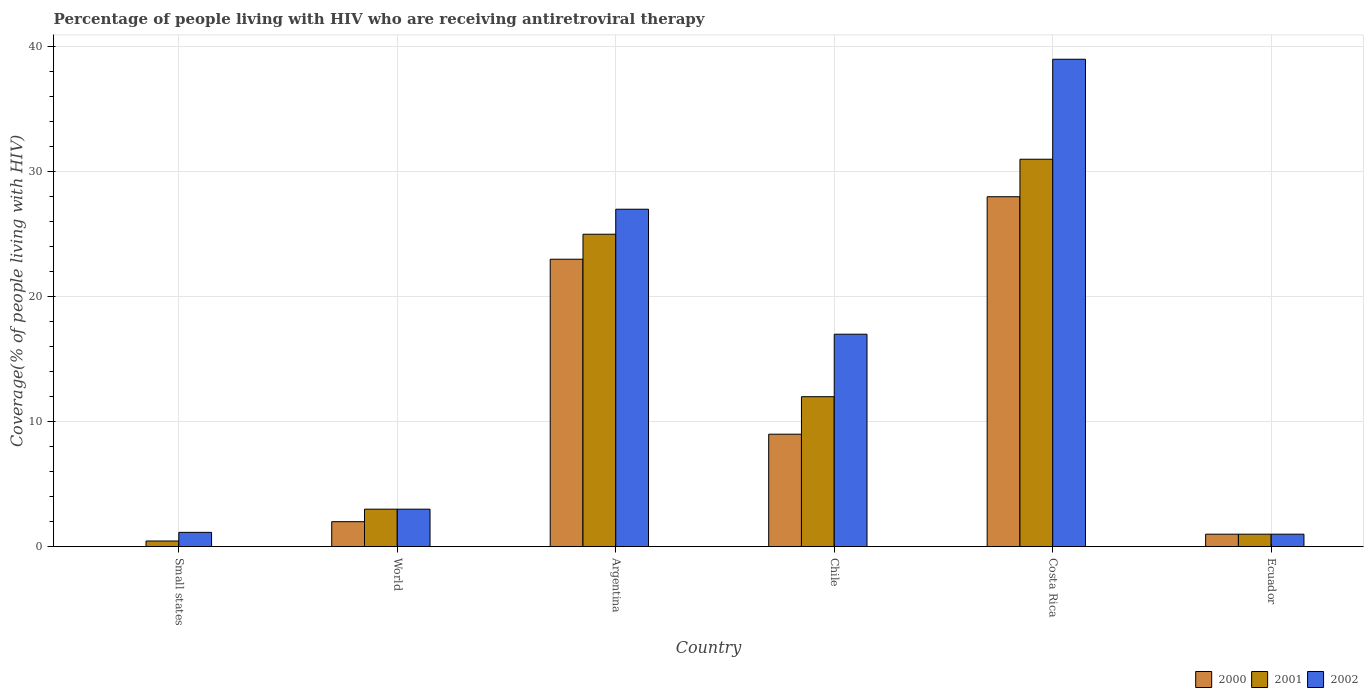What is the label of the 3rd group of bars from the left?
Provide a succinct answer. Argentina. In how many cases, is the number of bars for a given country not equal to the number of legend labels?
Provide a short and direct response. 0. What is the percentage of the HIV infected people who are receiving antiretroviral therapy in 2002 in Chile?
Provide a succinct answer. 17. Across all countries, what is the maximum percentage of the HIV infected people who are receiving antiretroviral therapy in 2002?
Your response must be concise. 39. In which country was the percentage of the HIV infected people who are receiving antiretroviral therapy in 2000 minimum?
Provide a succinct answer. Small states. What is the total percentage of the HIV infected people who are receiving antiretroviral therapy in 2001 in the graph?
Ensure brevity in your answer.  72.45. What is the difference between the percentage of the HIV infected people who are receiving antiretroviral therapy in 2002 in Ecuador and that in World?
Offer a terse response. -2. What is the difference between the percentage of the HIV infected people who are receiving antiretroviral therapy in 2002 in Chile and the percentage of the HIV infected people who are receiving antiretroviral therapy in 2001 in World?
Make the answer very short. 14. What is the average percentage of the HIV infected people who are receiving antiretroviral therapy in 2002 per country?
Provide a short and direct response. 14.69. What is the difference between the percentage of the HIV infected people who are receiving antiretroviral therapy of/in 2001 and percentage of the HIV infected people who are receiving antiretroviral therapy of/in 2002 in Small states?
Offer a very short reply. -0.69. What is the ratio of the percentage of the HIV infected people who are receiving antiretroviral therapy in 2001 in Costa Rica to that in Small states?
Offer a terse response. 68.14. Is the percentage of the HIV infected people who are receiving antiretroviral therapy in 2002 in Argentina less than that in Costa Rica?
Keep it short and to the point. Yes. Is the difference between the percentage of the HIV infected people who are receiving antiretroviral therapy in 2001 in Argentina and Chile greater than the difference between the percentage of the HIV infected people who are receiving antiretroviral therapy in 2002 in Argentina and Chile?
Your answer should be compact. Yes. What is the difference between the highest and the lowest percentage of the HIV infected people who are receiving antiretroviral therapy in 2002?
Provide a short and direct response. 38. In how many countries, is the percentage of the HIV infected people who are receiving antiretroviral therapy in 2002 greater than the average percentage of the HIV infected people who are receiving antiretroviral therapy in 2002 taken over all countries?
Offer a very short reply. 3. What does the 1st bar from the left in World represents?
Make the answer very short. 2000. What does the 1st bar from the right in World represents?
Make the answer very short. 2002. Is it the case that in every country, the sum of the percentage of the HIV infected people who are receiving antiretroviral therapy in 2000 and percentage of the HIV infected people who are receiving antiretroviral therapy in 2002 is greater than the percentage of the HIV infected people who are receiving antiretroviral therapy in 2001?
Give a very brief answer. Yes. How many bars are there?
Your response must be concise. 18. Are all the bars in the graph horizontal?
Provide a short and direct response. No. How many countries are there in the graph?
Offer a terse response. 6. What is the difference between two consecutive major ticks on the Y-axis?
Provide a short and direct response. 10. Does the graph contain any zero values?
Keep it short and to the point. No. Where does the legend appear in the graph?
Provide a succinct answer. Bottom right. How are the legend labels stacked?
Ensure brevity in your answer.  Horizontal. What is the title of the graph?
Offer a terse response. Percentage of people living with HIV who are receiving antiretroviral therapy. What is the label or title of the Y-axis?
Provide a succinct answer. Coverage(% of people living with HIV). What is the Coverage(% of people living with HIV) of 2000 in Small states?
Give a very brief answer. 0.01. What is the Coverage(% of people living with HIV) in 2001 in Small states?
Keep it short and to the point. 0.45. What is the Coverage(% of people living with HIV) of 2002 in Small states?
Ensure brevity in your answer.  1.15. What is the Coverage(% of people living with HIV) in 2001 in World?
Offer a very short reply. 3. What is the Coverage(% of people living with HIV) in 2000 in Chile?
Give a very brief answer. 9. What is the Coverage(% of people living with HIV) in 2000 in Costa Rica?
Make the answer very short. 28. What is the Coverage(% of people living with HIV) in 2001 in Costa Rica?
Give a very brief answer. 31. What is the Coverage(% of people living with HIV) of 2000 in Ecuador?
Your answer should be compact. 1. Across all countries, what is the minimum Coverage(% of people living with HIV) in 2000?
Your response must be concise. 0.01. Across all countries, what is the minimum Coverage(% of people living with HIV) of 2001?
Keep it short and to the point. 0.45. Across all countries, what is the minimum Coverage(% of people living with HIV) of 2002?
Provide a succinct answer. 1. What is the total Coverage(% of people living with HIV) in 2000 in the graph?
Provide a short and direct response. 63.01. What is the total Coverage(% of people living with HIV) of 2001 in the graph?
Offer a very short reply. 72.45. What is the total Coverage(% of people living with HIV) in 2002 in the graph?
Provide a succinct answer. 88.15. What is the difference between the Coverage(% of people living with HIV) of 2000 in Small states and that in World?
Give a very brief answer. -1.99. What is the difference between the Coverage(% of people living with HIV) of 2001 in Small states and that in World?
Your response must be concise. -2.54. What is the difference between the Coverage(% of people living with HIV) in 2002 in Small states and that in World?
Keep it short and to the point. -1.85. What is the difference between the Coverage(% of people living with HIV) in 2000 in Small states and that in Argentina?
Provide a short and direct response. -22.99. What is the difference between the Coverage(% of people living with HIV) in 2001 in Small states and that in Argentina?
Your answer should be very brief. -24.55. What is the difference between the Coverage(% of people living with HIV) of 2002 in Small states and that in Argentina?
Offer a very short reply. -25.85. What is the difference between the Coverage(% of people living with HIV) of 2000 in Small states and that in Chile?
Keep it short and to the point. -8.99. What is the difference between the Coverage(% of people living with HIV) of 2001 in Small states and that in Chile?
Make the answer very short. -11.54. What is the difference between the Coverage(% of people living with HIV) of 2002 in Small states and that in Chile?
Ensure brevity in your answer.  -15.85. What is the difference between the Coverage(% of people living with HIV) of 2000 in Small states and that in Costa Rica?
Your answer should be compact. -27.99. What is the difference between the Coverage(% of people living with HIV) of 2001 in Small states and that in Costa Rica?
Give a very brief answer. -30.55. What is the difference between the Coverage(% of people living with HIV) of 2002 in Small states and that in Costa Rica?
Your answer should be compact. -37.85. What is the difference between the Coverage(% of people living with HIV) in 2000 in Small states and that in Ecuador?
Give a very brief answer. -0.99. What is the difference between the Coverage(% of people living with HIV) in 2001 in Small states and that in Ecuador?
Keep it short and to the point. -0.55. What is the difference between the Coverage(% of people living with HIV) in 2002 in Small states and that in Ecuador?
Ensure brevity in your answer.  0.15. What is the difference between the Coverage(% of people living with HIV) in 2000 in World and that in Argentina?
Provide a short and direct response. -21. What is the difference between the Coverage(% of people living with HIV) of 2001 in World and that in Argentina?
Offer a very short reply. -22. What is the difference between the Coverage(% of people living with HIV) in 2002 in World and that in Argentina?
Your response must be concise. -24. What is the difference between the Coverage(% of people living with HIV) in 2000 in World and that in Chile?
Make the answer very short. -7. What is the difference between the Coverage(% of people living with HIV) of 2001 in World and that in Chile?
Give a very brief answer. -9. What is the difference between the Coverage(% of people living with HIV) of 2000 in World and that in Costa Rica?
Give a very brief answer. -26. What is the difference between the Coverage(% of people living with HIV) of 2001 in World and that in Costa Rica?
Your response must be concise. -28. What is the difference between the Coverage(% of people living with HIV) of 2002 in World and that in Costa Rica?
Provide a short and direct response. -36. What is the difference between the Coverage(% of people living with HIV) of 2000 in World and that in Ecuador?
Offer a very short reply. 1. What is the difference between the Coverage(% of people living with HIV) in 2002 in World and that in Ecuador?
Provide a succinct answer. 2. What is the difference between the Coverage(% of people living with HIV) in 2001 in Argentina and that in Chile?
Offer a very short reply. 13. What is the difference between the Coverage(% of people living with HIV) of 2000 in Argentina and that in Costa Rica?
Give a very brief answer. -5. What is the difference between the Coverage(% of people living with HIV) in 2002 in Argentina and that in Costa Rica?
Offer a very short reply. -12. What is the difference between the Coverage(% of people living with HIV) in 2002 in Argentina and that in Ecuador?
Provide a succinct answer. 26. What is the difference between the Coverage(% of people living with HIV) of 2000 in Chile and that in Costa Rica?
Offer a terse response. -19. What is the difference between the Coverage(% of people living with HIV) of 2001 in Chile and that in Costa Rica?
Provide a succinct answer. -19. What is the difference between the Coverage(% of people living with HIV) of 2002 in Chile and that in Ecuador?
Ensure brevity in your answer.  16. What is the difference between the Coverage(% of people living with HIV) in 2000 in Costa Rica and that in Ecuador?
Keep it short and to the point. 27. What is the difference between the Coverage(% of people living with HIV) of 2001 in Costa Rica and that in Ecuador?
Your answer should be very brief. 30. What is the difference between the Coverage(% of people living with HIV) of 2000 in Small states and the Coverage(% of people living with HIV) of 2001 in World?
Your answer should be compact. -2.99. What is the difference between the Coverage(% of people living with HIV) of 2000 in Small states and the Coverage(% of people living with HIV) of 2002 in World?
Provide a short and direct response. -2.99. What is the difference between the Coverage(% of people living with HIV) in 2001 in Small states and the Coverage(% of people living with HIV) in 2002 in World?
Your response must be concise. -2.54. What is the difference between the Coverage(% of people living with HIV) in 2000 in Small states and the Coverage(% of people living with HIV) in 2001 in Argentina?
Keep it short and to the point. -24.99. What is the difference between the Coverage(% of people living with HIV) in 2000 in Small states and the Coverage(% of people living with HIV) in 2002 in Argentina?
Provide a succinct answer. -26.99. What is the difference between the Coverage(% of people living with HIV) in 2001 in Small states and the Coverage(% of people living with HIV) in 2002 in Argentina?
Your response must be concise. -26.55. What is the difference between the Coverage(% of people living with HIV) of 2000 in Small states and the Coverage(% of people living with HIV) of 2001 in Chile?
Offer a terse response. -11.99. What is the difference between the Coverage(% of people living with HIV) in 2000 in Small states and the Coverage(% of people living with HIV) in 2002 in Chile?
Keep it short and to the point. -16.99. What is the difference between the Coverage(% of people living with HIV) of 2001 in Small states and the Coverage(% of people living with HIV) of 2002 in Chile?
Ensure brevity in your answer.  -16.55. What is the difference between the Coverage(% of people living with HIV) in 2000 in Small states and the Coverage(% of people living with HIV) in 2001 in Costa Rica?
Offer a very short reply. -30.99. What is the difference between the Coverage(% of people living with HIV) of 2000 in Small states and the Coverage(% of people living with HIV) of 2002 in Costa Rica?
Keep it short and to the point. -38.99. What is the difference between the Coverage(% of people living with HIV) in 2001 in Small states and the Coverage(% of people living with HIV) in 2002 in Costa Rica?
Your response must be concise. -38.55. What is the difference between the Coverage(% of people living with HIV) of 2000 in Small states and the Coverage(% of people living with HIV) of 2001 in Ecuador?
Your response must be concise. -0.99. What is the difference between the Coverage(% of people living with HIV) of 2000 in Small states and the Coverage(% of people living with HIV) of 2002 in Ecuador?
Your response must be concise. -0.99. What is the difference between the Coverage(% of people living with HIV) in 2001 in Small states and the Coverage(% of people living with HIV) in 2002 in Ecuador?
Make the answer very short. -0.55. What is the difference between the Coverage(% of people living with HIV) in 2000 in World and the Coverage(% of people living with HIV) in 2002 in Argentina?
Your response must be concise. -25. What is the difference between the Coverage(% of people living with HIV) of 2000 in World and the Coverage(% of people living with HIV) of 2002 in Chile?
Offer a very short reply. -15. What is the difference between the Coverage(% of people living with HIV) of 2000 in World and the Coverage(% of people living with HIV) of 2002 in Costa Rica?
Your answer should be very brief. -37. What is the difference between the Coverage(% of people living with HIV) in 2001 in World and the Coverage(% of people living with HIV) in 2002 in Costa Rica?
Offer a very short reply. -36. What is the difference between the Coverage(% of people living with HIV) of 2001 in World and the Coverage(% of people living with HIV) of 2002 in Ecuador?
Your response must be concise. 2. What is the difference between the Coverage(% of people living with HIV) of 2000 in Argentina and the Coverage(% of people living with HIV) of 2001 in Chile?
Give a very brief answer. 11. What is the difference between the Coverage(% of people living with HIV) of 2000 in Argentina and the Coverage(% of people living with HIV) of 2002 in Chile?
Keep it short and to the point. 6. What is the difference between the Coverage(% of people living with HIV) in 2000 in Argentina and the Coverage(% of people living with HIV) in 2002 in Costa Rica?
Your answer should be very brief. -16. What is the difference between the Coverage(% of people living with HIV) of 2000 in Argentina and the Coverage(% of people living with HIV) of 2001 in Ecuador?
Make the answer very short. 22. What is the difference between the Coverage(% of people living with HIV) of 2000 in Argentina and the Coverage(% of people living with HIV) of 2002 in Ecuador?
Your answer should be very brief. 22. What is the difference between the Coverage(% of people living with HIV) of 2000 in Chile and the Coverage(% of people living with HIV) of 2001 in Costa Rica?
Provide a short and direct response. -22. What is the difference between the Coverage(% of people living with HIV) of 2001 in Chile and the Coverage(% of people living with HIV) of 2002 in Costa Rica?
Offer a very short reply. -27. What is the difference between the Coverage(% of people living with HIV) of 2000 in Chile and the Coverage(% of people living with HIV) of 2001 in Ecuador?
Ensure brevity in your answer.  8. What is the difference between the Coverage(% of people living with HIV) in 2000 in Chile and the Coverage(% of people living with HIV) in 2002 in Ecuador?
Ensure brevity in your answer.  8. What is the average Coverage(% of people living with HIV) in 2000 per country?
Ensure brevity in your answer.  10.5. What is the average Coverage(% of people living with HIV) in 2001 per country?
Keep it short and to the point. 12.08. What is the average Coverage(% of people living with HIV) of 2002 per country?
Give a very brief answer. 14.69. What is the difference between the Coverage(% of people living with HIV) of 2000 and Coverage(% of people living with HIV) of 2001 in Small states?
Provide a short and direct response. -0.44. What is the difference between the Coverage(% of people living with HIV) of 2000 and Coverage(% of people living with HIV) of 2002 in Small states?
Make the answer very short. -1.13. What is the difference between the Coverage(% of people living with HIV) of 2001 and Coverage(% of people living with HIV) of 2002 in Small states?
Ensure brevity in your answer.  -0.69. What is the difference between the Coverage(% of people living with HIV) of 2001 and Coverage(% of people living with HIV) of 2002 in World?
Offer a terse response. 0. What is the difference between the Coverage(% of people living with HIV) in 2000 and Coverage(% of people living with HIV) in 2002 in Argentina?
Offer a terse response. -4. What is the difference between the Coverage(% of people living with HIV) in 2000 and Coverage(% of people living with HIV) in 2001 in Chile?
Your response must be concise. -3. What is the difference between the Coverage(% of people living with HIV) in 2001 and Coverage(% of people living with HIV) in 2002 in Chile?
Keep it short and to the point. -5. What is the difference between the Coverage(% of people living with HIV) in 2000 and Coverage(% of people living with HIV) in 2001 in Ecuador?
Your answer should be compact. 0. What is the difference between the Coverage(% of people living with HIV) in 2001 and Coverage(% of people living with HIV) in 2002 in Ecuador?
Your answer should be very brief. 0. What is the ratio of the Coverage(% of people living with HIV) in 2000 in Small states to that in World?
Your response must be concise. 0.01. What is the ratio of the Coverage(% of people living with HIV) in 2001 in Small states to that in World?
Your response must be concise. 0.15. What is the ratio of the Coverage(% of people living with HIV) in 2002 in Small states to that in World?
Offer a terse response. 0.38. What is the ratio of the Coverage(% of people living with HIV) in 2001 in Small states to that in Argentina?
Make the answer very short. 0.02. What is the ratio of the Coverage(% of people living with HIV) of 2002 in Small states to that in Argentina?
Your answer should be compact. 0.04. What is the ratio of the Coverage(% of people living with HIV) of 2000 in Small states to that in Chile?
Give a very brief answer. 0. What is the ratio of the Coverage(% of people living with HIV) in 2001 in Small states to that in Chile?
Make the answer very short. 0.04. What is the ratio of the Coverage(% of people living with HIV) of 2002 in Small states to that in Chile?
Provide a short and direct response. 0.07. What is the ratio of the Coverage(% of people living with HIV) of 2000 in Small states to that in Costa Rica?
Make the answer very short. 0. What is the ratio of the Coverage(% of people living with HIV) in 2001 in Small states to that in Costa Rica?
Ensure brevity in your answer.  0.01. What is the ratio of the Coverage(% of people living with HIV) in 2002 in Small states to that in Costa Rica?
Offer a very short reply. 0.03. What is the ratio of the Coverage(% of people living with HIV) in 2000 in Small states to that in Ecuador?
Provide a short and direct response. 0.01. What is the ratio of the Coverage(% of people living with HIV) of 2001 in Small states to that in Ecuador?
Give a very brief answer. 0.46. What is the ratio of the Coverage(% of people living with HIV) of 2002 in Small states to that in Ecuador?
Offer a terse response. 1.15. What is the ratio of the Coverage(% of people living with HIV) of 2000 in World to that in Argentina?
Your answer should be very brief. 0.09. What is the ratio of the Coverage(% of people living with HIV) in 2001 in World to that in Argentina?
Your answer should be very brief. 0.12. What is the ratio of the Coverage(% of people living with HIV) in 2000 in World to that in Chile?
Give a very brief answer. 0.22. What is the ratio of the Coverage(% of people living with HIV) of 2001 in World to that in Chile?
Give a very brief answer. 0.25. What is the ratio of the Coverage(% of people living with HIV) of 2002 in World to that in Chile?
Offer a terse response. 0.18. What is the ratio of the Coverage(% of people living with HIV) of 2000 in World to that in Costa Rica?
Keep it short and to the point. 0.07. What is the ratio of the Coverage(% of people living with HIV) of 2001 in World to that in Costa Rica?
Your answer should be compact. 0.1. What is the ratio of the Coverage(% of people living with HIV) in 2002 in World to that in Costa Rica?
Provide a short and direct response. 0.08. What is the ratio of the Coverage(% of people living with HIV) in 2000 in World to that in Ecuador?
Your answer should be compact. 2. What is the ratio of the Coverage(% of people living with HIV) of 2002 in World to that in Ecuador?
Offer a very short reply. 3. What is the ratio of the Coverage(% of people living with HIV) in 2000 in Argentina to that in Chile?
Offer a terse response. 2.56. What is the ratio of the Coverage(% of people living with HIV) in 2001 in Argentina to that in Chile?
Make the answer very short. 2.08. What is the ratio of the Coverage(% of people living with HIV) in 2002 in Argentina to that in Chile?
Provide a short and direct response. 1.59. What is the ratio of the Coverage(% of people living with HIV) of 2000 in Argentina to that in Costa Rica?
Your response must be concise. 0.82. What is the ratio of the Coverage(% of people living with HIV) in 2001 in Argentina to that in Costa Rica?
Keep it short and to the point. 0.81. What is the ratio of the Coverage(% of people living with HIV) of 2002 in Argentina to that in Costa Rica?
Your response must be concise. 0.69. What is the ratio of the Coverage(% of people living with HIV) in 2000 in Argentina to that in Ecuador?
Make the answer very short. 23. What is the ratio of the Coverage(% of people living with HIV) in 2001 in Argentina to that in Ecuador?
Keep it short and to the point. 25. What is the ratio of the Coverage(% of people living with HIV) in 2000 in Chile to that in Costa Rica?
Make the answer very short. 0.32. What is the ratio of the Coverage(% of people living with HIV) in 2001 in Chile to that in Costa Rica?
Provide a short and direct response. 0.39. What is the ratio of the Coverage(% of people living with HIV) of 2002 in Chile to that in Costa Rica?
Offer a very short reply. 0.44. What is the ratio of the Coverage(% of people living with HIV) in 2000 in Chile to that in Ecuador?
Your answer should be very brief. 9. What is the ratio of the Coverage(% of people living with HIV) of 2001 in Chile to that in Ecuador?
Make the answer very short. 12. What is the difference between the highest and the second highest Coverage(% of people living with HIV) in 2000?
Your answer should be very brief. 5. What is the difference between the highest and the second highest Coverage(% of people living with HIV) of 2002?
Your response must be concise. 12. What is the difference between the highest and the lowest Coverage(% of people living with HIV) in 2000?
Provide a short and direct response. 27.99. What is the difference between the highest and the lowest Coverage(% of people living with HIV) in 2001?
Offer a terse response. 30.55. 